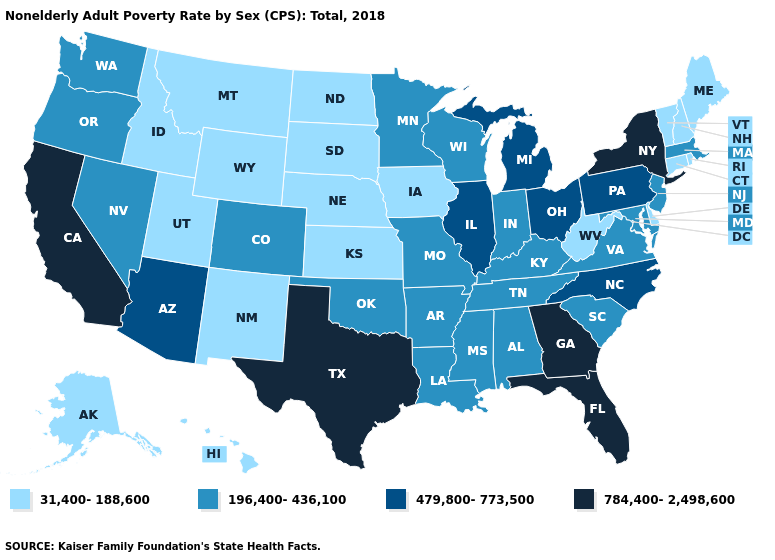Among the states that border Tennessee , does Georgia have the highest value?
Keep it brief. Yes. What is the lowest value in the USA?
Concise answer only. 31,400-188,600. Name the states that have a value in the range 784,400-2,498,600?
Quick response, please. California, Florida, Georgia, New York, Texas. Name the states that have a value in the range 479,800-773,500?
Quick response, please. Arizona, Illinois, Michigan, North Carolina, Ohio, Pennsylvania. What is the highest value in the USA?
Be succinct. 784,400-2,498,600. What is the value of Arizona?
Be succinct. 479,800-773,500. Which states hav the highest value in the Northeast?
Be succinct. New York. Name the states that have a value in the range 31,400-188,600?
Quick response, please. Alaska, Connecticut, Delaware, Hawaii, Idaho, Iowa, Kansas, Maine, Montana, Nebraska, New Hampshire, New Mexico, North Dakota, Rhode Island, South Dakota, Utah, Vermont, West Virginia, Wyoming. Name the states that have a value in the range 784,400-2,498,600?
Concise answer only. California, Florida, Georgia, New York, Texas. What is the value of West Virginia?
Short answer required. 31,400-188,600. What is the lowest value in states that border New York?
Quick response, please. 31,400-188,600. What is the highest value in the West ?
Concise answer only. 784,400-2,498,600. What is the value of Michigan?
Keep it brief. 479,800-773,500. Among the states that border Wyoming , which have the highest value?
Short answer required. Colorado. Is the legend a continuous bar?
Give a very brief answer. No. 